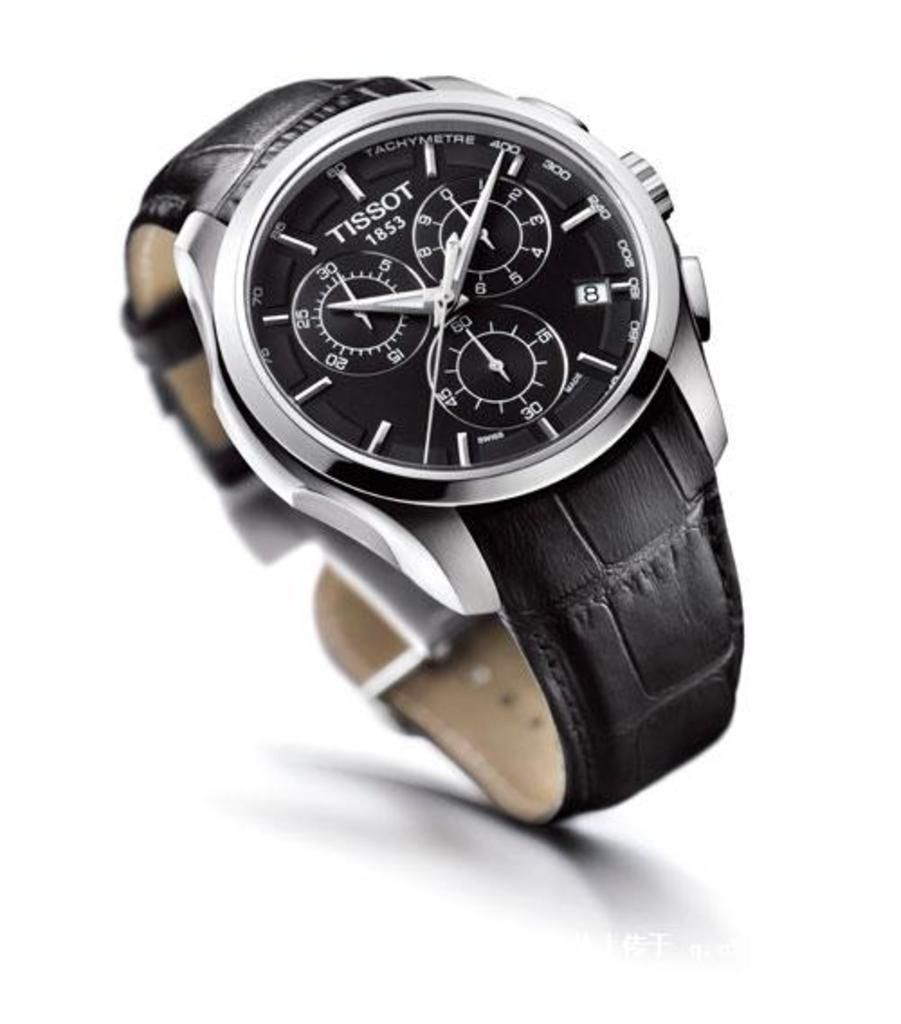<image>
Write a terse but informative summary of the picture. Black watch that has the word TISSOT on the face. 